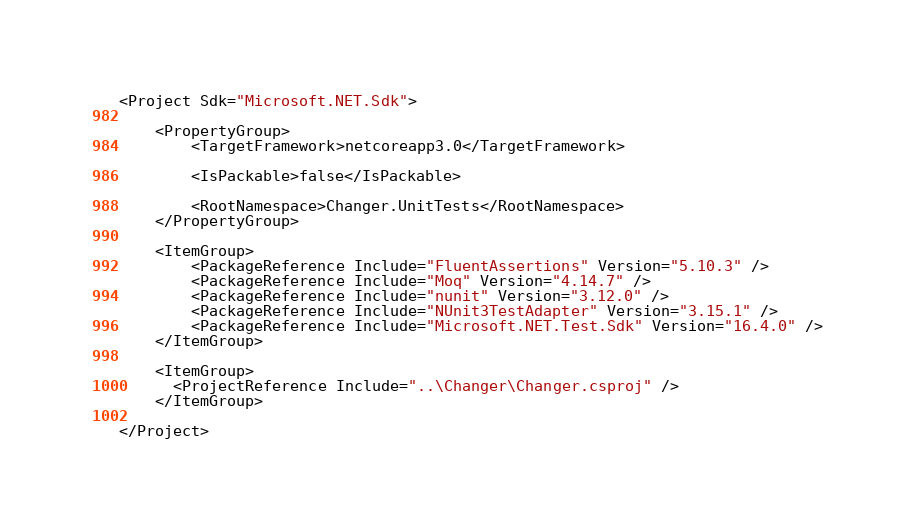<code> <loc_0><loc_0><loc_500><loc_500><_XML_><Project Sdk="Microsoft.NET.Sdk">

    <PropertyGroup>
        <TargetFramework>netcoreapp3.0</TargetFramework>

        <IsPackable>false</IsPackable>

        <RootNamespace>Changer.UnitTests</RootNamespace>
    </PropertyGroup>

    <ItemGroup>
        <PackageReference Include="FluentAssertions" Version="5.10.3" />
        <PackageReference Include="Moq" Version="4.14.7" />
        <PackageReference Include="nunit" Version="3.12.0" />
        <PackageReference Include="NUnit3TestAdapter" Version="3.15.1" />
        <PackageReference Include="Microsoft.NET.Test.Sdk" Version="16.4.0" />
    </ItemGroup>

    <ItemGroup>
      <ProjectReference Include="..\Changer\Changer.csproj" />
    </ItemGroup>

</Project>
</code> 